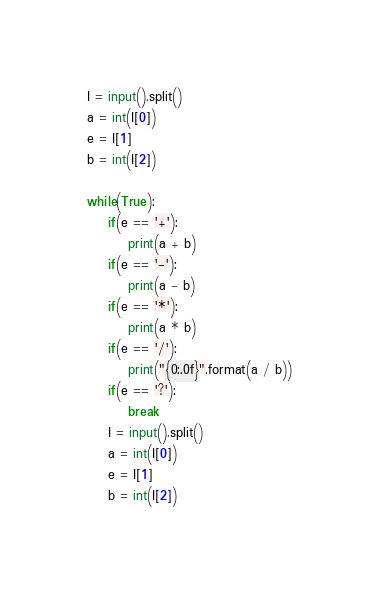Convert code to text. <code><loc_0><loc_0><loc_500><loc_500><_Python_>I = input().split()
a = int(I[0])
e = I[1]
b = int(I[2])

while(True):
    if(e == '+'):
        print(a + b)
    if(e == '-'):
        print(a - b)
    if(e == '*'):
        print(a * b)
    if(e == '/'):
        print("{0:.0f}".format(a / b))
    if(e == '?'):
        break
    I = input().split()
    a = int(I[0])
    e = I[1]
    b = int(I[2])</code> 